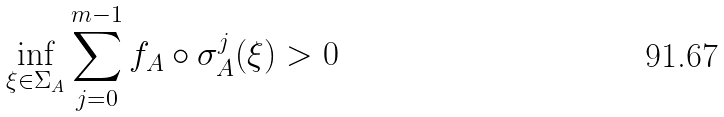<formula> <loc_0><loc_0><loc_500><loc_500>\inf _ { \xi \in \Sigma _ { A } } \sum _ { j = 0 } ^ { m - 1 } f _ { A } \circ \sigma _ { A } ^ { j } ( \xi ) > 0</formula> 